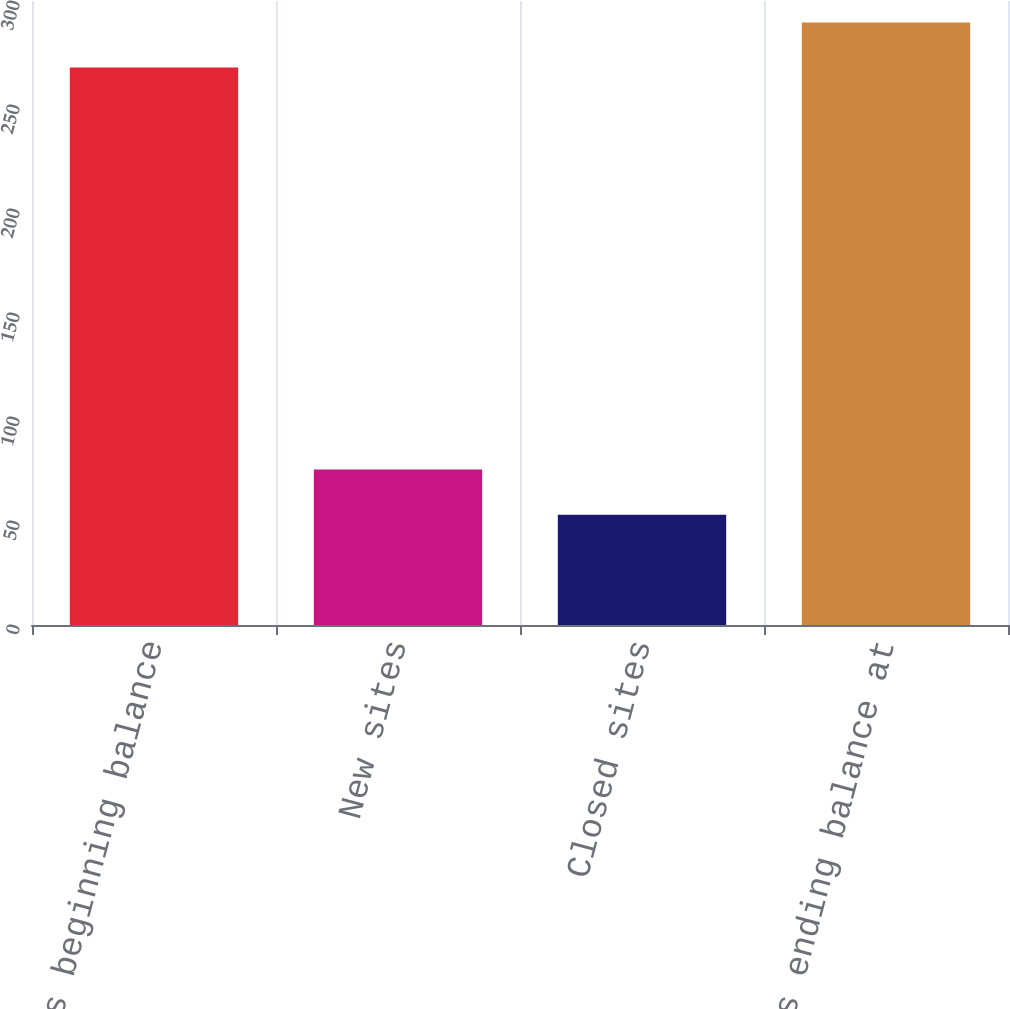Convert chart. <chart><loc_0><loc_0><loc_500><loc_500><bar_chart><fcel>Open sites beginning balance<fcel>New sites<fcel>Closed sites<fcel>Open sites ending balance at<nl><fcel>268<fcel>74.7<fcel>53<fcel>289.7<nl></chart> 